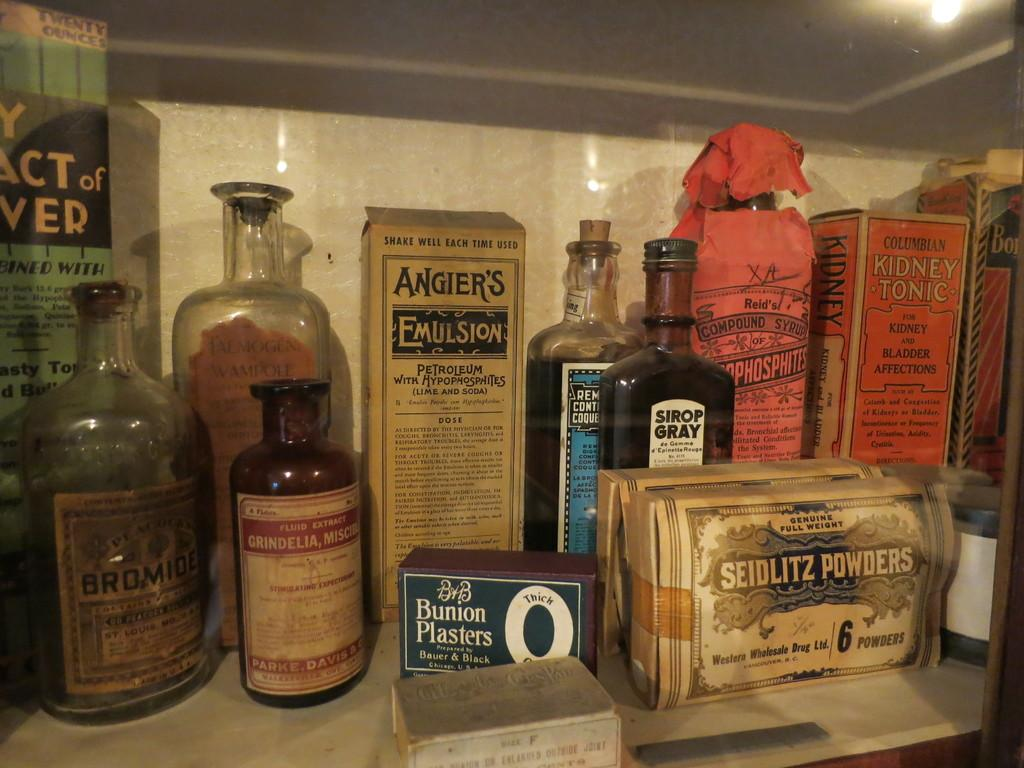<image>
Write a terse but informative summary of the picture. old medicine on a shelf that has one saying angiers emulsion 